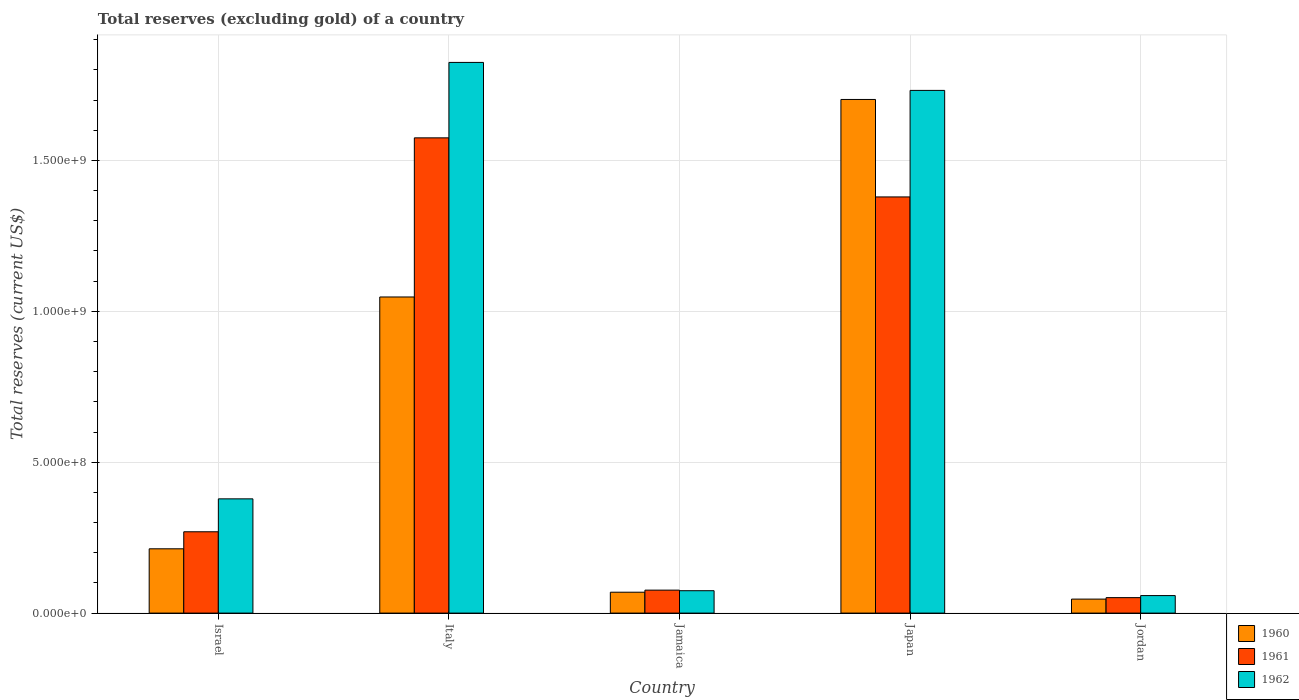How many different coloured bars are there?
Offer a terse response. 3. How many groups of bars are there?
Give a very brief answer. 5. Are the number of bars on each tick of the X-axis equal?
Keep it short and to the point. Yes. How many bars are there on the 2nd tick from the left?
Your answer should be compact. 3. What is the label of the 5th group of bars from the left?
Keep it short and to the point. Jordan. In how many cases, is the number of bars for a given country not equal to the number of legend labels?
Your response must be concise. 0. What is the total reserves (excluding gold) in 1960 in Jamaica?
Your answer should be very brief. 6.92e+07. Across all countries, what is the maximum total reserves (excluding gold) in 1961?
Your response must be concise. 1.57e+09. Across all countries, what is the minimum total reserves (excluding gold) in 1960?
Provide a succinct answer. 4.64e+07. In which country was the total reserves (excluding gold) in 1961 minimum?
Offer a very short reply. Jordan. What is the total total reserves (excluding gold) in 1961 in the graph?
Provide a succinct answer. 3.35e+09. What is the difference between the total reserves (excluding gold) in 1962 in Jamaica and that in Jordan?
Keep it short and to the point. 1.62e+07. What is the difference between the total reserves (excluding gold) in 1961 in Italy and the total reserves (excluding gold) in 1962 in Jordan?
Your answer should be very brief. 1.52e+09. What is the average total reserves (excluding gold) in 1960 per country?
Your answer should be very brief. 6.16e+08. What is the difference between the total reserves (excluding gold) of/in 1961 and total reserves (excluding gold) of/in 1960 in Jamaica?
Provide a succinct answer. 6.90e+06. In how many countries, is the total reserves (excluding gold) in 1962 greater than 1200000000 US$?
Offer a very short reply. 2. What is the ratio of the total reserves (excluding gold) in 1961 in Italy to that in Jordan?
Your answer should be very brief. 30.74. Is the difference between the total reserves (excluding gold) in 1961 in Italy and Jordan greater than the difference between the total reserves (excluding gold) in 1960 in Italy and Jordan?
Give a very brief answer. Yes. What is the difference between the highest and the second highest total reserves (excluding gold) in 1961?
Your answer should be very brief. 1.11e+09. What is the difference between the highest and the lowest total reserves (excluding gold) in 1961?
Give a very brief answer. 1.52e+09. Is it the case that in every country, the sum of the total reserves (excluding gold) in 1960 and total reserves (excluding gold) in 1962 is greater than the total reserves (excluding gold) in 1961?
Keep it short and to the point. Yes. What is the difference between two consecutive major ticks on the Y-axis?
Give a very brief answer. 5.00e+08. Are the values on the major ticks of Y-axis written in scientific E-notation?
Provide a short and direct response. Yes. How many legend labels are there?
Give a very brief answer. 3. What is the title of the graph?
Your response must be concise. Total reserves (excluding gold) of a country. What is the label or title of the Y-axis?
Keep it short and to the point. Total reserves (current US$). What is the Total reserves (current US$) in 1960 in Israel?
Provide a succinct answer. 2.13e+08. What is the Total reserves (current US$) in 1961 in Israel?
Ensure brevity in your answer.  2.69e+08. What is the Total reserves (current US$) of 1962 in Israel?
Provide a succinct answer. 3.79e+08. What is the Total reserves (current US$) in 1960 in Italy?
Ensure brevity in your answer.  1.05e+09. What is the Total reserves (current US$) of 1961 in Italy?
Provide a short and direct response. 1.57e+09. What is the Total reserves (current US$) of 1962 in Italy?
Offer a very short reply. 1.82e+09. What is the Total reserves (current US$) of 1960 in Jamaica?
Provide a short and direct response. 6.92e+07. What is the Total reserves (current US$) of 1961 in Jamaica?
Offer a very short reply. 7.61e+07. What is the Total reserves (current US$) of 1962 in Jamaica?
Your answer should be very brief. 7.42e+07. What is the Total reserves (current US$) in 1960 in Japan?
Make the answer very short. 1.70e+09. What is the Total reserves (current US$) of 1961 in Japan?
Give a very brief answer. 1.38e+09. What is the Total reserves (current US$) of 1962 in Japan?
Provide a succinct answer. 1.73e+09. What is the Total reserves (current US$) in 1960 in Jordan?
Your answer should be compact. 4.64e+07. What is the Total reserves (current US$) of 1961 in Jordan?
Your answer should be very brief. 5.12e+07. What is the Total reserves (current US$) in 1962 in Jordan?
Provide a short and direct response. 5.80e+07. Across all countries, what is the maximum Total reserves (current US$) of 1960?
Ensure brevity in your answer.  1.70e+09. Across all countries, what is the maximum Total reserves (current US$) in 1961?
Offer a very short reply. 1.57e+09. Across all countries, what is the maximum Total reserves (current US$) of 1962?
Ensure brevity in your answer.  1.82e+09. Across all countries, what is the minimum Total reserves (current US$) of 1960?
Keep it short and to the point. 4.64e+07. Across all countries, what is the minimum Total reserves (current US$) in 1961?
Your answer should be very brief. 5.12e+07. Across all countries, what is the minimum Total reserves (current US$) in 1962?
Offer a terse response. 5.80e+07. What is the total Total reserves (current US$) of 1960 in the graph?
Provide a short and direct response. 3.08e+09. What is the total Total reserves (current US$) in 1961 in the graph?
Provide a succinct answer. 3.35e+09. What is the total Total reserves (current US$) in 1962 in the graph?
Keep it short and to the point. 4.07e+09. What is the difference between the Total reserves (current US$) in 1960 in Israel and that in Italy?
Ensure brevity in your answer.  -8.34e+08. What is the difference between the Total reserves (current US$) of 1961 in Israel and that in Italy?
Give a very brief answer. -1.31e+09. What is the difference between the Total reserves (current US$) in 1962 in Israel and that in Italy?
Provide a succinct answer. -1.45e+09. What is the difference between the Total reserves (current US$) of 1960 in Israel and that in Jamaica?
Provide a succinct answer. 1.44e+08. What is the difference between the Total reserves (current US$) in 1961 in Israel and that in Jamaica?
Your response must be concise. 1.93e+08. What is the difference between the Total reserves (current US$) in 1962 in Israel and that in Jamaica?
Your answer should be compact. 3.04e+08. What is the difference between the Total reserves (current US$) in 1960 in Israel and that in Japan?
Offer a very short reply. -1.49e+09. What is the difference between the Total reserves (current US$) of 1961 in Israel and that in Japan?
Offer a terse response. -1.11e+09. What is the difference between the Total reserves (current US$) of 1962 in Israel and that in Japan?
Offer a terse response. -1.35e+09. What is the difference between the Total reserves (current US$) of 1960 in Israel and that in Jordan?
Provide a succinct answer. 1.67e+08. What is the difference between the Total reserves (current US$) of 1961 in Israel and that in Jordan?
Offer a terse response. 2.18e+08. What is the difference between the Total reserves (current US$) of 1962 in Israel and that in Jordan?
Provide a succinct answer. 3.21e+08. What is the difference between the Total reserves (current US$) in 1960 in Italy and that in Jamaica?
Your answer should be very brief. 9.78e+08. What is the difference between the Total reserves (current US$) of 1961 in Italy and that in Jamaica?
Your response must be concise. 1.50e+09. What is the difference between the Total reserves (current US$) of 1962 in Italy and that in Jamaica?
Keep it short and to the point. 1.75e+09. What is the difference between the Total reserves (current US$) of 1960 in Italy and that in Japan?
Keep it short and to the point. -6.55e+08. What is the difference between the Total reserves (current US$) of 1961 in Italy and that in Japan?
Provide a succinct answer. 1.96e+08. What is the difference between the Total reserves (current US$) of 1962 in Italy and that in Japan?
Offer a terse response. 9.27e+07. What is the difference between the Total reserves (current US$) in 1960 in Italy and that in Jordan?
Offer a very short reply. 1.00e+09. What is the difference between the Total reserves (current US$) in 1961 in Italy and that in Jordan?
Your response must be concise. 1.52e+09. What is the difference between the Total reserves (current US$) of 1962 in Italy and that in Jordan?
Keep it short and to the point. 1.77e+09. What is the difference between the Total reserves (current US$) in 1960 in Jamaica and that in Japan?
Your answer should be compact. -1.63e+09. What is the difference between the Total reserves (current US$) in 1961 in Jamaica and that in Japan?
Provide a succinct answer. -1.30e+09. What is the difference between the Total reserves (current US$) in 1962 in Jamaica and that in Japan?
Give a very brief answer. -1.66e+09. What is the difference between the Total reserves (current US$) of 1960 in Jamaica and that in Jordan?
Offer a very short reply. 2.28e+07. What is the difference between the Total reserves (current US$) of 1961 in Jamaica and that in Jordan?
Offer a terse response. 2.49e+07. What is the difference between the Total reserves (current US$) in 1962 in Jamaica and that in Jordan?
Offer a very short reply. 1.62e+07. What is the difference between the Total reserves (current US$) of 1960 in Japan and that in Jordan?
Provide a short and direct response. 1.66e+09. What is the difference between the Total reserves (current US$) of 1961 in Japan and that in Jordan?
Your answer should be compact. 1.33e+09. What is the difference between the Total reserves (current US$) of 1962 in Japan and that in Jordan?
Give a very brief answer. 1.67e+09. What is the difference between the Total reserves (current US$) in 1960 in Israel and the Total reserves (current US$) in 1961 in Italy?
Keep it short and to the point. -1.36e+09. What is the difference between the Total reserves (current US$) of 1960 in Israel and the Total reserves (current US$) of 1962 in Italy?
Provide a short and direct response. -1.61e+09. What is the difference between the Total reserves (current US$) of 1961 in Israel and the Total reserves (current US$) of 1962 in Italy?
Ensure brevity in your answer.  -1.56e+09. What is the difference between the Total reserves (current US$) of 1960 in Israel and the Total reserves (current US$) of 1961 in Jamaica?
Offer a very short reply. 1.37e+08. What is the difference between the Total reserves (current US$) in 1960 in Israel and the Total reserves (current US$) in 1962 in Jamaica?
Offer a terse response. 1.39e+08. What is the difference between the Total reserves (current US$) of 1961 in Israel and the Total reserves (current US$) of 1962 in Jamaica?
Your answer should be compact. 1.95e+08. What is the difference between the Total reserves (current US$) in 1960 in Israel and the Total reserves (current US$) in 1961 in Japan?
Give a very brief answer. -1.17e+09. What is the difference between the Total reserves (current US$) of 1960 in Israel and the Total reserves (current US$) of 1962 in Japan?
Your answer should be compact. -1.52e+09. What is the difference between the Total reserves (current US$) in 1961 in Israel and the Total reserves (current US$) in 1962 in Japan?
Offer a terse response. -1.46e+09. What is the difference between the Total reserves (current US$) in 1960 in Israel and the Total reserves (current US$) in 1961 in Jordan?
Offer a terse response. 1.62e+08. What is the difference between the Total reserves (current US$) of 1960 in Israel and the Total reserves (current US$) of 1962 in Jordan?
Offer a terse response. 1.55e+08. What is the difference between the Total reserves (current US$) in 1961 in Israel and the Total reserves (current US$) in 1962 in Jordan?
Offer a terse response. 2.11e+08. What is the difference between the Total reserves (current US$) in 1960 in Italy and the Total reserves (current US$) in 1961 in Jamaica?
Give a very brief answer. 9.71e+08. What is the difference between the Total reserves (current US$) of 1960 in Italy and the Total reserves (current US$) of 1962 in Jamaica?
Give a very brief answer. 9.73e+08. What is the difference between the Total reserves (current US$) in 1961 in Italy and the Total reserves (current US$) in 1962 in Jamaica?
Give a very brief answer. 1.50e+09. What is the difference between the Total reserves (current US$) in 1960 in Italy and the Total reserves (current US$) in 1961 in Japan?
Your answer should be very brief. -3.32e+08. What is the difference between the Total reserves (current US$) of 1960 in Italy and the Total reserves (current US$) of 1962 in Japan?
Offer a terse response. -6.85e+08. What is the difference between the Total reserves (current US$) in 1961 in Italy and the Total reserves (current US$) in 1962 in Japan?
Offer a very short reply. -1.57e+08. What is the difference between the Total reserves (current US$) of 1960 in Italy and the Total reserves (current US$) of 1961 in Jordan?
Give a very brief answer. 9.96e+08. What is the difference between the Total reserves (current US$) in 1960 in Italy and the Total reserves (current US$) in 1962 in Jordan?
Ensure brevity in your answer.  9.89e+08. What is the difference between the Total reserves (current US$) in 1961 in Italy and the Total reserves (current US$) in 1962 in Jordan?
Your response must be concise. 1.52e+09. What is the difference between the Total reserves (current US$) in 1960 in Jamaica and the Total reserves (current US$) in 1961 in Japan?
Provide a succinct answer. -1.31e+09. What is the difference between the Total reserves (current US$) in 1960 in Jamaica and the Total reserves (current US$) in 1962 in Japan?
Make the answer very short. -1.66e+09. What is the difference between the Total reserves (current US$) of 1961 in Jamaica and the Total reserves (current US$) of 1962 in Japan?
Ensure brevity in your answer.  -1.66e+09. What is the difference between the Total reserves (current US$) of 1960 in Jamaica and the Total reserves (current US$) of 1961 in Jordan?
Offer a very short reply. 1.80e+07. What is the difference between the Total reserves (current US$) of 1960 in Jamaica and the Total reserves (current US$) of 1962 in Jordan?
Your answer should be compact. 1.12e+07. What is the difference between the Total reserves (current US$) in 1961 in Jamaica and the Total reserves (current US$) in 1962 in Jordan?
Offer a very short reply. 1.81e+07. What is the difference between the Total reserves (current US$) in 1960 in Japan and the Total reserves (current US$) in 1961 in Jordan?
Your answer should be very brief. 1.65e+09. What is the difference between the Total reserves (current US$) in 1960 in Japan and the Total reserves (current US$) in 1962 in Jordan?
Offer a very short reply. 1.64e+09. What is the difference between the Total reserves (current US$) in 1961 in Japan and the Total reserves (current US$) in 1962 in Jordan?
Your answer should be compact. 1.32e+09. What is the average Total reserves (current US$) in 1960 per country?
Offer a very short reply. 6.16e+08. What is the average Total reserves (current US$) of 1961 per country?
Offer a very short reply. 6.70e+08. What is the average Total reserves (current US$) of 1962 per country?
Keep it short and to the point. 8.14e+08. What is the difference between the Total reserves (current US$) in 1960 and Total reserves (current US$) in 1961 in Israel?
Keep it short and to the point. -5.64e+07. What is the difference between the Total reserves (current US$) in 1960 and Total reserves (current US$) in 1962 in Israel?
Offer a terse response. -1.66e+08. What is the difference between the Total reserves (current US$) of 1961 and Total reserves (current US$) of 1962 in Israel?
Your answer should be very brief. -1.09e+08. What is the difference between the Total reserves (current US$) in 1960 and Total reserves (current US$) in 1961 in Italy?
Your answer should be compact. -5.27e+08. What is the difference between the Total reserves (current US$) in 1960 and Total reserves (current US$) in 1962 in Italy?
Your answer should be very brief. -7.77e+08. What is the difference between the Total reserves (current US$) of 1961 and Total reserves (current US$) of 1962 in Italy?
Provide a succinct answer. -2.50e+08. What is the difference between the Total reserves (current US$) in 1960 and Total reserves (current US$) in 1961 in Jamaica?
Ensure brevity in your answer.  -6.90e+06. What is the difference between the Total reserves (current US$) of 1960 and Total reserves (current US$) of 1962 in Jamaica?
Provide a short and direct response. -5.00e+06. What is the difference between the Total reserves (current US$) of 1961 and Total reserves (current US$) of 1962 in Jamaica?
Give a very brief answer. 1.90e+06. What is the difference between the Total reserves (current US$) in 1960 and Total reserves (current US$) in 1961 in Japan?
Keep it short and to the point. 3.23e+08. What is the difference between the Total reserves (current US$) of 1960 and Total reserves (current US$) of 1962 in Japan?
Ensure brevity in your answer.  -3.00e+07. What is the difference between the Total reserves (current US$) in 1961 and Total reserves (current US$) in 1962 in Japan?
Offer a very short reply. -3.53e+08. What is the difference between the Total reserves (current US$) in 1960 and Total reserves (current US$) in 1961 in Jordan?
Your response must be concise. -4.85e+06. What is the difference between the Total reserves (current US$) of 1960 and Total reserves (current US$) of 1962 in Jordan?
Offer a terse response. -1.17e+07. What is the difference between the Total reserves (current US$) of 1961 and Total reserves (current US$) of 1962 in Jordan?
Ensure brevity in your answer.  -6.82e+06. What is the ratio of the Total reserves (current US$) in 1960 in Israel to that in Italy?
Offer a terse response. 0.2. What is the ratio of the Total reserves (current US$) of 1961 in Israel to that in Italy?
Offer a terse response. 0.17. What is the ratio of the Total reserves (current US$) in 1962 in Israel to that in Italy?
Your answer should be compact. 0.21. What is the ratio of the Total reserves (current US$) of 1960 in Israel to that in Jamaica?
Provide a short and direct response. 3.08. What is the ratio of the Total reserves (current US$) of 1961 in Israel to that in Jamaica?
Give a very brief answer. 3.54. What is the ratio of the Total reserves (current US$) of 1962 in Israel to that in Jamaica?
Your answer should be very brief. 5.1. What is the ratio of the Total reserves (current US$) of 1960 in Israel to that in Japan?
Offer a terse response. 0.13. What is the ratio of the Total reserves (current US$) of 1961 in Israel to that in Japan?
Provide a short and direct response. 0.2. What is the ratio of the Total reserves (current US$) in 1962 in Israel to that in Japan?
Your response must be concise. 0.22. What is the ratio of the Total reserves (current US$) of 1960 in Israel to that in Jordan?
Make the answer very short. 4.59. What is the ratio of the Total reserves (current US$) of 1961 in Israel to that in Jordan?
Offer a terse response. 5.26. What is the ratio of the Total reserves (current US$) in 1962 in Israel to that in Jordan?
Keep it short and to the point. 6.52. What is the ratio of the Total reserves (current US$) of 1960 in Italy to that in Jamaica?
Keep it short and to the point. 15.14. What is the ratio of the Total reserves (current US$) in 1961 in Italy to that in Jamaica?
Your response must be concise. 20.69. What is the ratio of the Total reserves (current US$) of 1962 in Italy to that in Jamaica?
Your response must be concise. 24.59. What is the ratio of the Total reserves (current US$) of 1960 in Italy to that in Japan?
Offer a terse response. 0.62. What is the ratio of the Total reserves (current US$) in 1961 in Italy to that in Japan?
Your answer should be compact. 1.14. What is the ratio of the Total reserves (current US$) in 1962 in Italy to that in Japan?
Offer a terse response. 1.05. What is the ratio of the Total reserves (current US$) in 1960 in Italy to that in Jordan?
Make the answer very short. 22.59. What is the ratio of the Total reserves (current US$) of 1961 in Italy to that in Jordan?
Your answer should be very brief. 30.74. What is the ratio of the Total reserves (current US$) of 1962 in Italy to that in Jordan?
Offer a very short reply. 31.43. What is the ratio of the Total reserves (current US$) of 1960 in Jamaica to that in Japan?
Keep it short and to the point. 0.04. What is the ratio of the Total reserves (current US$) of 1961 in Jamaica to that in Japan?
Your answer should be compact. 0.06. What is the ratio of the Total reserves (current US$) in 1962 in Jamaica to that in Japan?
Give a very brief answer. 0.04. What is the ratio of the Total reserves (current US$) in 1960 in Jamaica to that in Jordan?
Ensure brevity in your answer.  1.49. What is the ratio of the Total reserves (current US$) in 1961 in Jamaica to that in Jordan?
Ensure brevity in your answer.  1.49. What is the ratio of the Total reserves (current US$) of 1962 in Jamaica to that in Jordan?
Offer a very short reply. 1.28. What is the ratio of the Total reserves (current US$) of 1960 in Japan to that in Jordan?
Ensure brevity in your answer.  36.7. What is the ratio of the Total reserves (current US$) in 1961 in Japan to that in Jordan?
Make the answer very short. 26.92. What is the ratio of the Total reserves (current US$) of 1962 in Japan to that in Jordan?
Provide a succinct answer. 29.84. What is the difference between the highest and the second highest Total reserves (current US$) in 1960?
Offer a terse response. 6.55e+08. What is the difference between the highest and the second highest Total reserves (current US$) in 1961?
Provide a short and direct response. 1.96e+08. What is the difference between the highest and the second highest Total reserves (current US$) of 1962?
Make the answer very short. 9.27e+07. What is the difference between the highest and the lowest Total reserves (current US$) in 1960?
Your answer should be very brief. 1.66e+09. What is the difference between the highest and the lowest Total reserves (current US$) of 1961?
Offer a terse response. 1.52e+09. What is the difference between the highest and the lowest Total reserves (current US$) in 1962?
Make the answer very short. 1.77e+09. 